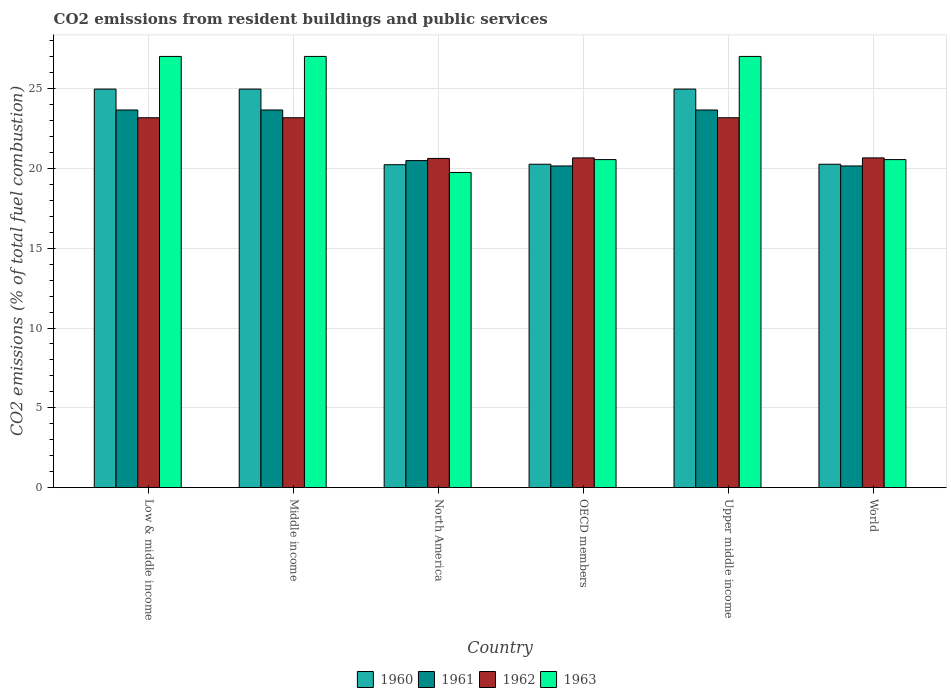How many different coloured bars are there?
Offer a very short reply. 4. How many bars are there on the 5th tick from the left?
Provide a succinct answer. 4. How many bars are there on the 2nd tick from the right?
Offer a very short reply. 4. In how many cases, is the number of bars for a given country not equal to the number of legend labels?
Your answer should be compact. 0. What is the total CO2 emitted in 1961 in World?
Your response must be concise. 20.15. Across all countries, what is the maximum total CO2 emitted in 1962?
Your answer should be compact. 23.17. Across all countries, what is the minimum total CO2 emitted in 1961?
Ensure brevity in your answer.  20.15. In which country was the total CO2 emitted in 1962 minimum?
Provide a succinct answer. North America. What is the total total CO2 emitted in 1962 in the graph?
Keep it short and to the point. 131.46. What is the difference between the total CO2 emitted in 1963 in OECD members and that in Upper middle income?
Provide a succinct answer. -6.46. What is the difference between the total CO2 emitted in 1963 in Upper middle income and the total CO2 emitted in 1962 in Middle income?
Give a very brief answer. 3.84. What is the average total CO2 emitted in 1960 per country?
Keep it short and to the point. 22.61. What is the difference between the total CO2 emitted of/in 1963 and total CO2 emitted of/in 1960 in World?
Offer a very short reply. 0.29. In how many countries, is the total CO2 emitted in 1961 greater than 6?
Provide a succinct answer. 6. What is the ratio of the total CO2 emitted in 1963 in Low & middle income to that in North America?
Make the answer very short. 1.37. Is the total CO2 emitted in 1962 in Low & middle income less than that in North America?
Offer a terse response. No. Is the difference between the total CO2 emitted in 1963 in OECD members and World greater than the difference between the total CO2 emitted in 1960 in OECD members and World?
Make the answer very short. No. What is the difference between the highest and the lowest total CO2 emitted in 1963?
Ensure brevity in your answer.  7.27. In how many countries, is the total CO2 emitted in 1960 greater than the average total CO2 emitted in 1960 taken over all countries?
Give a very brief answer. 3. Is it the case that in every country, the sum of the total CO2 emitted in 1962 and total CO2 emitted in 1961 is greater than the sum of total CO2 emitted in 1960 and total CO2 emitted in 1963?
Offer a very short reply. Yes. How many countries are there in the graph?
Keep it short and to the point. 6. What is the difference between two consecutive major ticks on the Y-axis?
Ensure brevity in your answer.  5. Does the graph contain any zero values?
Give a very brief answer. No. Does the graph contain grids?
Your answer should be very brief. Yes. Where does the legend appear in the graph?
Ensure brevity in your answer.  Bottom center. How many legend labels are there?
Ensure brevity in your answer.  4. How are the legend labels stacked?
Make the answer very short. Horizontal. What is the title of the graph?
Provide a short and direct response. CO2 emissions from resident buildings and public services. Does "1994" appear as one of the legend labels in the graph?
Ensure brevity in your answer.  No. What is the label or title of the Y-axis?
Offer a terse response. CO2 emissions (% of total fuel combustion). What is the CO2 emissions (% of total fuel combustion) of 1960 in Low & middle income?
Keep it short and to the point. 24.97. What is the CO2 emissions (% of total fuel combustion) of 1961 in Low & middle income?
Offer a terse response. 23.66. What is the CO2 emissions (% of total fuel combustion) of 1962 in Low & middle income?
Give a very brief answer. 23.17. What is the CO2 emissions (% of total fuel combustion) in 1963 in Low & middle income?
Provide a succinct answer. 27.01. What is the CO2 emissions (% of total fuel combustion) in 1960 in Middle income?
Offer a terse response. 24.97. What is the CO2 emissions (% of total fuel combustion) of 1961 in Middle income?
Give a very brief answer. 23.66. What is the CO2 emissions (% of total fuel combustion) of 1962 in Middle income?
Give a very brief answer. 23.17. What is the CO2 emissions (% of total fuel combustion) of 1963 in Middle income?
Your answer should be very brief. 27.01. What is the CO2 emissions (% of total fuel combustion) in 1960 in North America?
Keep it short and to the point. 20.23. What is the CO2 emissions (% of total fuel combustion) in 1961 in North America?
Your response must be concise. 20.49. What is the CO2 emissions (% of total fuel combustion) of 1962 in North America?
Your response must be concise. 20.62. What is the CO2 emissions (% of total fuel combustion) of 1963 in North America?
Give a very brief answer. 19.74. What is the CO2 emissions (% of total fuel combustion) in 1960 in OECD members?
Your answer should be very brief. 20.26. What is the CO2 emissions (% of total fuel combustion) of 1961 in OECD members?
Give a very brief answer. 20.15. What is the CO2 emissions (% of total fuel combustion) in 1962 in OECD members?
Provide a short and direct response. 20.66. What is the CO2 emissions (% of total fuel combustion) in 1963 in OECD members?
Provide a short and direct response. 20.55. What is the CO2 emissions (% of total fuel combustion) of 1960 in Upper middle income?
Provide a short and direct response. 24.97. What is the CO2 emissions (% of total fuel combustion) in 1961 in Upper middle income?
Offer a very short reply. 23.66. What is the CO2 emissions (% of total fuel combustion) of 1962 in Upper middle income?
Offer a terse response. 23.17. What is the CO2 emissions (% of total fuel combustion) of 1963 in Upper middle income?
Ensure brevity in your answer.  27.01. What is the CO2 emissions (% of total fuel combustion) of 1960 in World?
Provide a succinct answer. 20.26. What is the CO2 emissions (% of total fuel combustion) in 1961 in World?
Give a very brief answer. 20.15. What is the CO2 emissions (% of total fuel combustion) of 1962 in World?
Make the answer very short. 20.66. What is the CO2 emissions (% of total fuel combustion) in 1963 in World?
Offer a terse response. 20.55. Across all countries, what is the maximum CO2 emissions (% of total fuel combustion) of 1960?
Your response must be concise. 24.97. Across all countries, what is the maximum CO2 emissions (% of total fuel combustion) of 1961?
Offer a very short reply. 23.66. Across all countries, what is the maximum CO2 emissions (% of total fuel combustion) of 1962?
Provide a succinct answer. 23.17. Across all countries, what is the maximum CO2 emissions (% of total fuel combustion) in 1963?
Offer a terse response. 27.01. Across all countries, what is the minimum CO2 emissions (% of total fuel combustion) of 1960?
Your answer should be compact. 20.23. Across all countries, what is the minimum CO2 emissions (% of total fuel combustion) in 1961?
Offer a very short reply. 20.15. Across all countries, what is the minimum CO2 emissions (% of total fuel combustion) in 1962?
Your response must be concise. 20.62. Across all countries, what is the minimum CO2 emissions (% of total fuel combustion) of 1963?
Offer a very short reply. 19.74. What is the total CO2 emissions (% of total fuel combustion) of 1960 in the graph?
Your answer should be very brief. 135.66. What is the total CO2 emissions (% of total fuel combustion) in 1961 in the graph?
Your response must be concise. 131.78. What is the total CO2 emissions (% of total fuel combustion) in 1962 in the graph?
Provide a short and direct response. 131.46. What is the total CO2 emissions (% of total fuel combustion) of 1963 in the graph?
Your response must be concise. 141.89. What is the difference between the CO2 emissions (% of total fuel combustion) in 1963 in Low & middle income and that in Middle income?
Give a very brief answer. 0. What is the difference between the CO2 emissions (% of total fuel combustion) of 1960 in Low & middle income and that in North America?
Your answer should be very brief. 4.74. What is the difference between the CO2 emissions (% of total fuel combustion) of 1961 in Low & middle income and that in North America?
Provide a succinct answer. 3.17. What is the difference between the CO2 emissions (% of total fuel combustion) in 1962 in Low & middle income and that in North America?
Keep it short and to the point. 2.55. What is the difference between the CO2 emissions (% of total fuel combustion) of 1963 in Low & middle income and that in North America?
Offer a terse response. 7.27. What is the difference between the CO2 emissions (% of total fuel combustion) in 1960 in Low & middle income and that in OECD members?
Provide a succinct answer. 4.71. What is the difference between the CO2 emissions (% of total fuel combustion) of 1961 in Low & middle income and that in OECD members?
Provide a short and direct response. 3.51. What is the difference between the CO2 emissions (% of total fuel combustion) of 1962 in Low & middle income and that in OECD members?
Keep it short and to the point. 2.52. What is the difference between the CO2 emissions (% of total fuel combustion) of 1963 in Low & middle income and that in OECD members?
Ensure brevity in your answer.  6.46. What is the difference between the CO2 emissions (% of total fuel combustion) in 1960 in Low & middle income and that in Upper middle income?
Provide a succinct answer. 0. What is the difference between the CO2 emissions (% of total fuel combustion) of 1962 in Low & middle income and that in Upper middle income?
Offer a very short reply. 0. What is the difference between the CO2 emissions (% of total fuel combustion) in 1963 in Low & middle income and that in Upper middle income?
Give a very brief answer. 0. What is the difference between the CO2 emissions (% of total fuel combustion) in 1960 in Low & middle income and that in World?
Offer a very short reply. 4.71. What is the difference between the CO2 emissions (% of total fuel combustion) of 1961 in Low & middle income and that in World?
Your answer should be very brief. 3.51. What is the difference between the CO2 emissions (% of total fuel combustion) in 1962 in Low & middle income and that in World?
Make the answer very short. 2.52. What is the difference between the CO2 emissions (% of total fuel combustion) of 1963 in Low & middle income and that in World?
Your answer should be compact. 6.46. What is the difference between the CO2 emissions (% of total fuel combustion) in 1960 in Middle income and that in North America?
Ensure brevity in your answer.  4.74. What is the difference between the CO2 emissions (% of total fuel combustion) in 1961 in Middle income and that in North America?
Your answer should be very brief. 3.17. What is the difference between the CO2 emissions (% of total fuel combustion) in 1962 in Middle income and that in North America?
Provide a short and direct response. 2.55. What is the difference between the CO2 emissions (% of total fuel combustion) of 1963 in Middle income and that in North America?
Make the answer very short. 7.27. What is the difference between the CO2 emissions (% of total fuel combustion) of 1960 in Middle income and that in OECD members?
Your answer should be very brief. 4.71. What is the difference between the CO2 emissions (% of total fuel combustion) in 1961 in Middle income and that in OECD members?
Offer a very short reply. 3.51. What is the difference between the CO2 emissions (% of total fuel combustion) of 1962 in Middle income and that in OECD members?
Keep it short and to the point. 2.52. What is the difference between the CO2 emissions (% of total fuel combustion) in 1963 in Middle income and that in OECD members?
Keep it short and to the point. 6.46. What is the difference between the CO2 emissions (% of total fuel combustion) in 1962 in Middle income and that in Upper middle income?
Provide a short and direct response. 0. What is the difference between the CO2 emissions (% of total fuel combustion) of 1960 in Middle income and that in World?
Your answer should be very brief. 4.71. What is the difference between the CO2 emissions (% of total fuel combustion) of 1961 in Middle income and that in World?
Make the answer very short. 3.51. What is the difference between the CO2 emissions (% of total fuel combustion) of 1962 in Middle income and that in World?
Your answer should be very brief. 2.52. What is the difference between the CO2 emissions (% of total fuel combustion) in 1963 in Middle income and that in World?
Ensure brevity in your answer.  6.46. What is the difference between the CO2 emissions (% of total fuel combustion) in 1960 in North America and that in OECD members?
Your response must be concise. -0.03. What is the difference between the CO2 emissions (% of total fuel combustion) of 1961 in North America and that in OECD members?
Offer a terse response. 0.34. What is the difference between the CO2 emissions (% of total fuel combustion) in 1962 in North America and that in OECD members?
Ensure brevity in your answer.  -0.03. What is the difference between the CO2 emissions (% of total fuel combustion) of 1963 in North America and that in OECD members?
Offer a very short reply. -0.81. What is the difference between the CO2 emissions (% of total fuel combustion) of 1960 in North America and that in Upper middle income?
Provide a short and direct response. -4.74. What is the difference between the CO2 emissions (% of total fuel combustion) of 1961 in North America and that in Upper middle income?
Give a very brief answer. -3.17. What is the difference between the CO2 emissions (% of total fuel combustion) in 1962 in North America and that in Upper middle income?
Make the answer very short. -2.55. What is the difference between the CO2 emissions (% of total fuel combustion) of 1963 in North America and that in Upper middle income?
Provide a short and direct response. -7.27. What is the difference between the CO2 emissions (% of total fuel combustion) in 1960 in North America and that in World?
Provide a short and direct response. -0.03. What is the difference between the CO2 emissions (% of total fuel combustion) of 1961 in North America and that in World?
Ensure brevity in your answer.  0.34. What is the difference between the CO2 emissions (% of total fuel combustion) in 1962 in North America and that in World?
Your answer should be compact. -0.03. What is the difference between the CO2 emissions (% of total fuel combustion) in 1963 in North America and that in World?
Keep it short and to the point. -0.81. What is the difference between the CO2 emissions (% of total fuel combustion) in 1960 in OECD members and that in Upper middle income?
Keep it short and to the point. -4.71. What is the difference between the CO2 emissions (% of total fuel combustion) in 1961 in OECD members and that in Upper middle income?
Provide a succinct answer. -3.51. What is the difference between the CO2 emissions (% of total fuel combustion) in 1962 in OECD members and that in Upper middle income?
Offer a very short reply. -2.52. What is the difference between the CO2 emissions (% of total fuel combustion) in 1963 in OECD members and that in Upper middle income?
Offer a terse response. -6.46. What is the difference between the CO2 emissions (% of total fuel combustion) of 1960 in OECD members and that in World?
Keep it short and to the point. 0. What is the difference between the CO2 emissions (% of total fuel combustion) of 1961 in OECD members and that in World?
Provide a short and direct response. 0. What is the difference between the CO2 emissions (% of total fuel combustion) in 1962 in OECD members and that in World?
Provide a short and direct response. 0. What is the difference between the CO2 emissions (% of total fuel combustion) of 1960 in Upper middle income and that in World?
Give a very brief answer. 4.71. What is the difference between the CO2 emissions (% of total fuel combustion) of 1961 in Upper middle income and that in World?
Your answer should be very brief. 3.51. What is the difference between the CO2 emissions (% of total fuel combustion) of 1962 in Upper middle income and that in World?
Provide a succinct answer. 2.52. What is the difference between the CO2 emissions (% of total fuel combustion) in 1963 in Upper middle income and that in World?
Provide a short and direct response. 6.46. What is the difference between the CO2 emissions (% of total fuel combustion) in 1960 in Low & middle income and the CO2 emissions (% of total fuel combustion) in 1961 in Middle income?
Keep it short and to the point. 1.31. What is the difference between the CO2 emissions (% of total fuel combustion) of 1960 in Low & middle income and the CO2 emissions (% of total fuel combustion) of 1962 in Middle income?
Ensure brevity in your answer.  1.8. What is the difference between the CO2 emissions (% of total fuel combustion) of 1960 in Low & middle income and the CO2 emissions (% of total fuel combustion) of 1963 in Middle income?
Ensure brevity in your answer.  -2.05. What is the difference between the CO2 emissions (% of total fuel combustion) in 1961 in Low & middle income and the CO2 emissions (% of total fuel combustion) in 1962 in Middle income?
Offer a terse response. 0.49. What is the difference between the CO2 emissions (% of total fuel combustion) in 1961 in Low & middle income and the CO2 emissions (% of total fuel combustion) in 1963 in Middle income?
Offer a very short reply. -3.35. What is the difference between the CO2 emissions (% of total fuel combustion) in 1962 in Low & middle income and the CO2 emissions (% of total fuel combustion) in 1963 in Middle income?
Offer a very short reply. -3.84. What is the difference between the CO2 emissions (% of total fuel combustion) of 1960 in Low & middle income and the CO2 emissions (% of total fuel combustion) of 1961 in North America?
Your answer should be very brief. 4.48. What is the difference between the CO2 emissions (% of total fuel combustion) of 1960 in Low & middle income and the CO2 emissions (% of total fuel combustion) of 1962 in North America?
Keep it short and to the point. 4.35. What is the difference between the CO2 emissions (% of total fuel combustion) of 1960 in Low & middle income and the CO2 emissions (% of total fuel combustion) of 1963 in North America?
Offer a very short reply. 5.22. What is the difference between the CO2 emissions (% of total fuel combustion) in 1961 in Low & middle income and the CO2 emissions (% of total fuel combustion) in 1962 in North America?
Provide a short and direct response. 3.04. What is the difference between the CO2 emissions (% of total fuel combustion) in 1961 in Low & middle income and the CO2 emissions (% of total fuel combustion) in 1963 in North America?
Ensure brevity in your answer.  3.92. What is the difference between the CO2 emissions (% of total fuel combustion) of 1962 in Low & middle income and the CO2 emissions (% of total fuel combustion) of 1963 in North America?
Offer a very short reply. 3.43. What is the difference between the CO2 emissions (% of total fuel combustion) in 1960 in Low & middle income and the CO2 emissions (% of total fuel combustion) in 1961 in OECD members?
Keep it short and to the point. 4.82. What is the difference between the CO2 emissions (% of total fuel combustion) in 1960 in Low & middle income and the CO2 emissions (% of total fuel combustion) in 1962 in OECD members?
Ensure brevity in your answer.  4.31. What is the difference between the CO2 emissions (% of total fuel combustion) in 1960 in Low & middle income and the CO2 emissions (% of total fuel combustion) in 1963 in OECD members?
Provide a short and direct response. 4.42. What is the difference between the CO2 emissions (% of total fuel combustion) of 1961 in Low & middle income and the CO2 emissions (% of total fuel combustion) of 1962 in OECD members?
Make the answer very short. 3. What is the difference between the CO2 emissions (% of total fuel combustion) in 1961 in Low & middle income and the CO2 emissions (% of total fuel combustion) in 1963 in OECD members?
Keep it short and to the point. 3.11. What is the difference between the CO2 emissions (% of total fuel combustion) in 1962 in Low & middle income and the CO2 emissions (% of total fuel combustion) in 1963 in OECD members?
Offer a very short reply. 2.62. What is the difference between the CO2 emissions (% of total fuel combustion) of 1960 in Low & middle income and the CO2 emissions (% of total fuel combustion) of 1961 in Upper middle income?
Provide a succinct answer. 1.31. What is the difference between the CO2 emissions (% of total fuel combustion) in 1960 in Low & middle income and the CO2 emissions (% of total fuel combustion) in 1962 in Upper middle income?
Provide a succinct answer. 1.8. What is the difference between the CO2 emissions (% of total fuel combustion) in 1960 in Low & middle income and the CO2 emissions (% of total fuel combustion) in 1963 in Upper middle income?
Offer a very short reply. -2.05. What is the difference between the CO2 emissions (% of total fuel combustion) in 1961 in Low & middle income and the CO2 emissions (% of total fuel combustion) in 1962 in Upper middle income?
Make the answer very short. 0.49. What is the difference between the CO2 emissions (% of total fuel combustion) in 1961 in Low & middle income and the CO2 emissions (% of total fuel combustion) in 1963 in Upper middle income?
Your answer should be very brief. -3.35. What is the difference between the CO2 emissions (% of total fuel combustion) in 1962 in Low & middle income and the CO2 emissions (% of total fuel combustion) in 1963 in Upper middle income?
Offer a terse response. -3.84. What is the difference between the CO2 emissions (% of total fuel combustion) in 1960 in Low & middle income and the CO2 emissions (% of total fuel combustion) in 1961 in World?
Your response must be concise. 4.82. What is the difference between the CO2 emissions (% of total fuel combustion) in 1960 in Low & middle income and the CO2 emissions (% of total fuel combustion) in 1962 in World?
Provide a succinct answer. 4.31. What is the difference between the CO2 emissions (% of total fuel combustion) in 1960 in Low & middle income and the CO2 emissions (% of total fuel combustion) in 1963 in World?
Your response must be concise. 4.42. What is the difference between the CO2 emissions (% of total fuel combustion) in 1961 in Low & middle income and the CO2 emissions (% of total fuel combustion) in 1962 in World?
Your response must be concise. 3. What is the difference between the CO2 emissions (% of total fuel combustion) of 1961 in Low & middle income and the CO2 emissions (% of total fuel combustion) of 1963 in World?
Provide a short and direct response. 3.11. What is the difference between the CO2 emissions (% of total fuel combustion) of 1962 in Low & middle income and the CO2 emissions (% of total fuel combustion) of 1963 in World?
Provide a succinct answer. 2.62. What is the difference between the CO2 emissions (% of total fuel combustion) in 1960 in Middle income and the CO2 emissions (% of total fuel combustion) in 1961 in North America?
Your answer should be very brief. 4.48. What is the difference between the CO2 emissions (% of total fuel combustion) of 1960 in Middle income and the CO2 emissions (% of total fuel combustion) of 1962 in North America?
Ensure brevity in your answer.  4.35. What is the difference between the CO2 emissions (% of total fuel combustion) of 1960 in Middle income and the CO2 emissions (% of total fuel combustion) of 1963 in North America?
Offer a terse response. 5.22. What is the difference between the CO2 emissions (% of total fuel combustion) of 1961 in Middle income and the CO2 emissions (% of total fuel combustion) of 1962 in North America?
Your answer should be compact. 3.04. What is the difference between the CO2 emissions (% of total fuel combustion) of 1961 in Middle income and the CO2 emissions (% of total fuel combustion) of 1963 in North America?
Provide a succinct answer. 3.92. What is the difference between the CO2 emissions (% of total fuel combustion) in 1962 in Middle income and the CO2 emissions (% of total fuel combustion) in 1963 in North America?
Make the answer very short. 3.43. What is the difference between the CO2 emissions (% of total fuel combustion) in 1960 in Middle income and the CO2 emissions (% of total fuel combustion) in 1961 in OECD members?
Your answer should be compact. 4.82. What is the difference between the CO2 emissions (% of total fuel combustion) of 1960 in Middle income and the CO2 emissions (% of total fuel combustion) of 1962 in OECD members?
Provide a succinct answer. 4.31. What is the difference between the CO2 emissions (% of total fuel combustion) in 1960 in Middle income and the CO2 emissions (% of total fuel combustion) in 1963 in OECD members?
Your answer should be very brief. 4.42. What is the difference between the CO2 emissions (% of total fuel combustion) in 1961 in Middle income and the CO2 emissions (% of total fuel combustion) in 1962 in OECD members?
Keep it short and to the point. 3. What is the difference between the CO2 emissions (% of total fuel combustion) of 1961 in Middle income and the CO2 emissions (% of total fuel combustion) of 1963 in OECD members?
Provide a succinct answer. 3.11. What is the difference between the CO2 emissions (% of total fuel combustion) in 1962 in Middle income and the CO2 emissions (% of total fuel combustion) in 1963 in OECD members?
Provide a short and direct response. 2.62. What is the difference between the CO2 emissions (% of total fuel combustion) of 1960 in Middle income and the CO2 emissions (% of total fuel combustion) of 1961 in Upper middle income?
Your answer should be very brief. 1.31. What is the difference between the CO2 emissions (% of total fuel combustion) in 1960 in Middle income and the CO2 emissions (% of total fuel combustion) in 1962 in Upper middle income?
Give a very brief answer. 1.8. What is the difference between the CO2 emissions (% of total fuel combustion) in 1960 in Middle income and the CO2 emissions (% of total fuel combustion) in 1963 in Upper middle income?
Provide a succinct answer. -2.05. What is the difference between the CO2 emissions (% of total fuel combustion) in 1961 in Middle income and the CO2 emissions (% of total fuel combustion) in 1962 in Upper middle income?
Offer a very short reply. 0.49. What is the difference between the CO2 emissions (% of total fuel combustion) of 1961 in Middle income and the CO2 emissions (% of total fuel combustion) of 1963 in Upper middle income?
Your response must be concise. -3.35. What is the difference between the CO2 emissions (% of total fuel combustion) in 1962 in Middle income and the CO2 emissions (% of total fuel combustion) in 1963 in Upper middle income?
Provide a short and direct response. -3.84. What is the difference between the CO2 emissions (% of total fuel combustion) in 1960 in Middle income and the CO2 emissions (% of total fuel combustion) in 1961 in World?
Make the answer very short. 4.82. What is the difference between the CO2 emissions (% of total fuel combustion) of 1960 in Middle income and the CO2 emissions (% of total fuel combustion) of 1962 in World?
Make the answer very short. 4.31. What is the difference between the CO2 emissions (% of total fuel combustion) of 1960 in Middle income and the CO2 emissions (% of total fuel combustion) of 1963 in World?
Make the answer very short. 4.42. What is the difference between the CO2 emissions (% of total fuel combustion) in 1961 in Middle income and the CO2 emissions (% of total fuel combustion) in 1962 in World?
Offer a terse response. 3. What is the difference between the CO2 emissions (% of total fuel combustion) in 1961 in Middle income and the CO2 emissions (% of total fuel combustion) in 1963 in World?
Offer a very short reply. 3.11. What is the difference between the CO2 emissions (% of total fuel combustion) in 1962 in Middle income and the CO2 emissions (% of total fuel combustion) in 1963 in World?
Your answer should be very brief. 2.62. What is the difference between the CO2 emissions (% of total fuel combustion) in 1960 in North America and the CO2 emissions (% of total fuel combustion) in 1961 in OECD members?
Give a very brief answer. 0.08. What is the difference between the CO2 emissions (% of total fuel combustion) in 1960 in North America and the CO2 emissions (% of total fuel combustion) in 1962 in OECD members?
Give a very brief answer. -0.43. What is the difference between the CO2 emissions (% of total fuel combustion) of 1960 in North America and the CO2 emissions (% of total fuel combustion) of 1963 in OECD members?
Offer a very short reply. -0.32. What is the difference between the CO2 emissions (% of total fuel combustion) of 1961 in North America and the CO2 emissions (% of total fuel combustion) of 1962 in OECD members?
Offer a terse response. -0.17. What is the difference between the CO2 emissions (% of total fuel combustion) in 1961 in North America and the CO2 emissions (% of total fuel combustion) in 1963 in OECD members?
Give a very brief answer. -0.06. What is the difference between the CO2 emissions (% of total fuel combustion) in 1962 in North America and the CO2 emissions (% of total fuel combustion) in 1963 in OECD members?
Offer a very short reply. 0.07. What is the difference between the CO2 emissions (% of total fuel combustion) of 1960 in North America and the CO2 emissions (% of total fuel combustion) of 1961 in Upper middle income?
Give a very brief answer. -3.43. What is the difference between the CO2 emissions (% of total fuel combustion) in 1960 in North America and the CO2 emissions (% of total fuel combustion) in 1962 in Upper middle income?
Ensure brevity in your answer.  -2.94. What is the difference between the CO2 emissions (% of total fuel combustion) in 1960 in North America and the CO2 emissions (% of total fuel combustion) in 1963 in Upper middle income?
Offer a terse response. -6.78. What is the difference between the CO2 emissions (% of total fuel combustion) of 1961 in North America and the CO2 emissions (% of total fuel combustion) of 1962 in Upper middle income?
Your answer should be very brief. -2.68. What is the difference between the CO2 emissions (% of total fuel combustion) in 1961 in North America and the CO2 emissions (% of total fuel combustion) in 1963 in Upper middle income?
Keep it short and to the point. -6.53. What is the difference between the CO2 emissions (% of total fuel combustion) of 1962 in North America and the CO2 emissions (% of total fuel combustion) of 1963 in Upper middle income?
Your answer should be very brief. -6.39. What is the difference between the CO2 emissions (% of total fuel combustion) of 1960 in North America and the CO2 emissions (% of total fuel combustion) of 1961 in World?
Offer a terse response. 0.08. What is the difference between the CO2 emissions (% of total fuel combustion) in 1960 in North America and the CO2 emissions (% of total fuel combustion) in 1962 in World?
Your answer should be very brief. -0.43. What is the difference between the CO2 emissions (% of total fuel combustion) of 1960 in North America and the CO2 emissions (% of total fuel combustion) of 1963 in World?
Offer a very short reply. -0.32. What is the difference between the CO2 emissions (% of total fuel combustion) of 1961 in North America and the CO2 emissions (% of total fuel combustion) of 1962 in World?
Offer a very short reply. -0.17. What is the difference between the CO2 emissions (% of total fuel combustion) of 1961 in North America and the CO2 emissions (% of total fuel combustion) of 1963 in World?
Your response must be concise. -0.06. What is the difference between the CO2 emissions (% of total fuel combustion) of 1962 in North America and the CO2 emissions (% of total fuel combustion) of 1963 in World?
Make the answer very short. 0.07. What is the difference between the CO2 emissions (% of total fuel combustion) of 1960 in OECD members and the CO2 emissions (% of total fuel combustion) of 1961 in Upper middle income?
Your answer should be compact. -3.4. What is the difference between the CO2 emissions (% of total fuel combustion) in 1960 in OECD members and the CO2 emissions (% of total fuel combustion) in 1962 in Upper middle income?
Keep it short and to the point. -2.91. What is the difference between the CO2 emissions (% of total fuel combustion) of 1960 in OECD members and the CO2 emissions (% of total fuel combustion) of 1963 in Upper middle income?
Ensure brevity in your answer.  -6.75. What is the difference between the CO2 emissions (% of total fuel combustion) of 1961 in OECD members and the CO2 emissions (% of total fuel combustion) of 1962 in Upper middle income?
Make the answer very short. -3.02. What is the difference between the CO2 emissions (% of total fuel combustion) of 1961 in OECD members and the CO2 emissions (% of total fuel combustion) of 1963 in Upper middle income?
Your answer should be compact. -6.86. What is the difference between the CO2 emissions (% of total fuel combustion) in 1962 in OECD members and the CO2 emissions (% of total fuel combustion) in 1963 in Upper middle income?
Make the answer very short. -6.36. What is the difference between the CO2 emissions (% of total fuel combustion) of 1960 in OECD members and the CO2 emissions (% of total fuel combustion) of 1961 in World?
Offer a terse response. 0.11. What is the difference between the CO2 emissions (% of total fuel combustion) in 1960 in OECD members and the CO2 emissions (% of total fuel combustion) in 1962 in World?
Give a very brief answer. -0.4. What is the difference between the CO2 emissions (% of total fuel combustion) of 1960 in OECD members and the CO2 emissions (% of total fuel combustion) of 1963 in World?
Your answer should be compact. -0.29. What is the difference between the CO2 emissions (% of total fuel combustion) in 1961 in OECD members and the CO2 emissions (% of total fuel combustion) in 1962 in World?
Provide a succinct answer. -0.5. What is the difference between the CO2 emissions (% of total fuel combustion) in 1961 in OECD members and the CO2 emissions (% of total fuel combustion) in 1963 in World?
Your answer should be very brief. -0.4. What is the difference between the CO2 emissions (% of total fuel combustion) in 1962 in OECD members and the CO2 emissions (% of total fuel combustion) in 1963 in World?
Your answer should be compact. 0.11. What is the difference between the CO2 emissions (% of total fuel combustion) of 1960 in Upper middle income and the CO2 emissions (% of total fuel combustion) of 1961 in World?
Your answer should be compact. 4.82. What is the difference between the CO2 emissions (% of total fuel combustion) in 1960 in Upper middle income and the CO2 emissions (% of total fuel combustion) in 1962 in World?
Offer a very short reply. 4.31. What is the difference between the CO2 emissions (% of total fuel combustion) of 1960 in Upper middle income and the CO2 emissions (% of total fuel combustion) of 1963 in World?
Keep it short and to the point. 4.42. What is the difference between the CO2 emissions (% of total fuel combustion) of 1961 in Upper middle income and the CO2 emissions (% of total fuel combustion) of 1962 in World?
Ensure brevity in your answer.  3. What is the difference between the CO2 emissions (% of total fuel combustion) of 1961 in Upper middle income and the CO2 emissions (% of total fuel combustion) of 1963 in World?
Ensure brevity in your answer.  3.11. What is the difference between the CO2 emissions (% of total fuel combustion) in 1962 in Upper middle income and the CO2 emissions (% of total fuel combustion) in 1963 in World?
Give a very brief answer. 2.62. What is the average CO2 emissions (% of total fuel combustion) in 1960 per country?
Ensure brevity in your answer.  22.61. What is the average CO2 emissions (% of total fuel combustion) of 1961 per country?
Your answer should be very brief. 21.96. What is the average CO2 emissions (% of total fuel combustion) in 1962 per country?
Give a very brief answer. 21.91. What is the average CO2 emissions (% of total fuel combustion) in 1963 per country?
Your response must be concise. 23.65. What is the difference between the CO2 emissions (% of total fuel combustion) of 1960 and CO2 emissions (% of total fuel combustion) of 1961 in Low & middle income?
Make the answer very short. 1.31. What is the difference between the CO2 emissions (% of total fuel combustion) of 1960 and CO2 emissions (% of total fuel combustion) of 1962 in Low & middle income?
Provide a short and direct response. 1.8. What is the difference between the CO2 emissions (% of total fuel combustion) in 1960 and CO2 emissions (% of total fuel combustion) in 1963 in Low & middle income?
Your answer should be compact. -2.05. What is the difference between the CO2 emissions (% of total fuel combustion) of 1961 and CO2 emissions (% of total fuel combustion) of 1962 in Low & middle income?
Provide a short and direct response. 0.49. What is the difference between the CO2 emissions (% of total fuel combustion) in 1961 and CO2 emissions (% of total fuel combustion) in 1963 in Low & middle income?
Your response must be concise. -3.35. What is the difference between the CO2 emissions (% of total fuel combustion) of 1962 and CO2 emissions (% of total fuel combustion) of 1963 in Low & middle income?
Offer a very short reply. -3.84. What is the difference between the CO2 emissions (% of total fuel combustion) in 1960 and CO2 emissions (% of total fuel combustion) in 1961 in Middle income?
Your response must be concise. 1.31. What is the difference between the CO2 emissions (% of total fuel combustion) in 1960 and CO2 emissions (% of total fuel combustion) in 1962 in Middle income?
Your answer should be very brief. 1.8. What is the difference between the CO2 emissions (% of total fuel combustion) in 1960 and CO2 emissions (% of total fuel combustion) in 1963 in Middle income?
Your response must be concise. -2.05. What is the difference between the CO2 emissions (% of total fuel combustion) of 1961 and CO2 emissions (% of total fuel combustion) of 1962 in Middle income?
Offer a very short reply. 0.49. What is the difference between the CO2 emissions (% of total fuel combustion) in 1961 and CO2 emissions (% of total fuel combustion) in 1963 in Middle income?
Your answer should be very brief. -3.35. What is the difference between the CO2 emissions (% of total fuel combustion) of 1962 and CO2 emissions (% of total fuel combustion) of 1963 in Middle income?
Your answer should be very brief. -3.84. What is the difference between the CO2 emissions (% of total fuel combustion) in 1960 and CO2 emissions (% of total fuel combustion) in 1961 in North America?
Your response must be concise. -0.26. What is the difference between the CO2 emissions (% of total fuel combustion) of 1960 and CO2 emissions (% of total fuel combustion) of 1962 in North America?
Provide a short and direct response. -0.39. What is the difference between the CO2 emissions (% of total fuel combustion) in 1960 and CO2 emissions (% of total fuel combustion) in 1963 in North America?
Keep it short and to the point. 0.49. What is the difference between the CO2 emissions (% of total fuel combustion) in 1961 and CO2 emissions (% of total fuel combustion) in 1962 in North America?
Your response must be concise. -0.14. What is the difference between the CO2 emissions (% of total fuel combustion) of 1961 and CO2 emissions (% of total fuel combustion) of 1963 in North America?
Ensure brevity in your answer.  0.74. What is the difference between the CO2 emissions (% of total fuel combustion) in 1962 and CO2 emissions (% of total fuel combustion) in 1963 in North America?
Keep it short and to the point. 0.88. What is the difference between the CO2 emissions (% of total fuel combustion) in 1960 and CO2 emissions (% of total fuel combustion) in 1961 in OECD members?
Make the answer very short. 0.11. What is the difference between the CO2 emissions (% of total fuel combustion) of 1960 and CO2 emissions (% of total fuel combustion) of 1962 in OECD members?
Offer a very short reply. -0.4. What is the difference between the CO2 emissions (% of total fuel combustion) of 1960 and CO2 emissions (% of total fuel combustion) of 1963 in OECD members?
Provide a short and direct response. -0.29. What is the difference between the CO2 emissions (% of total fuel combustion) of 1961 and CO2 emissions (% of total fuel combustion) of 1962 in OECD members?
Offer a terse response. -0.5. What is the difference between the CO2 emissions (% of total fuel combustion) of 1961 and CO2 emissions (% of total fuel combustion) of 1963 in OECD members?
Your answer should be compact. -0.4. What is the difference between the CO2 emissions (% of total fuel combustion) of 1962 and CO2 emissions (% of total fuel combustion) of 1963 in OECD members?
Provide a short and direct response. 0.11. What is the difference between the CO2 emissions (% of total fuel combustion) in 1960 and CO2 emissions (% of total fuel combustion) in 1961 in Upper middle income?
Offer a terse response. 1.31. What is the difference between the CO2 emissions (% of total fuel combustion) of 1960 and CO2 emissions (% of total fuel combustion) of 1962 in Upper middle income?
Your answer should be compact. 1.8. What is the difference between the CO2 emissions (% of total fuel combustion) in 1960 and CO2 emissions (% of total fuel combustion) in 1963 in Upper middle income?
Give a very brief answer. -2.05. What is the difference between the CO2 emissions (% of total fuel combustion) in 1961 and CO2 emissions (% of total fuel combustion) in 1962 in Upper middle income?
Provide a succinct answer. 0.49. What is the difference between the CO2 emissions (% of total fuel combustion) of 1961 and CO2 emissions (% of total fuel combustion) of 1963 in Upper middle income?
Offer a very short reply. -3.35. What is the difference between the CO2 emissions (% of total fuel combustion) in 1962 and CO2 emissions (% of total fuel combustion) in 1963 in Upper middle income?
Offer a very short reply. -3.84. What is the difference between the CO2 emissions (% of total fuel combustion) in 1960 and CO2 emissions (% of total fuel combustion) in 1961 in World?
Give a very brief answer. 0.11. What is the difference between the CO2 emissions (% of total fuel combustion) in 1960 and CO2 emissions (% of total fuel combustion) in 1962 in World?
Offer a terse response. -0.4. What is the difference between the CO2 emissions (% of total fuel combustion) in 1960 and CO2 emissions (% of total fuel combustion) in 1963 in World?
Your response must be concise. -0.29. What is the difference between the CO2 emissions (% of total fuel combustion) of 1961 and CO2 emissions (% of total fuel combustion) of 1962 in World?
Offer a terse response. -0.5. What is the difference between the CO2 emissions (% of total fuel combustion) in 1961 and CO2 emissions (% of total fuel combustion) in 1963 in World?
Offer a very short reply. -0.4. What is the difference between the CO2 emissions (% of total fuel combustion) in 1962 and CO2 emissions (% of total fuel combustion) in 1963 in World?
Keep it short and to the point. 0.11. What is the ratio of the CO2 emissions (% of total fuel combustion) of 1962 in Low & middle income to that in Middle income?
Provide a short and direct response. 1. What is the ratio of the CO2 emissions (% of total fuel combustion) in 1963 in Low & middle income to that in Middle income?
Provide a short and direct response. 1. What is the ratio of the CO2 emissions (% of total fuel combustion) of 1960 in Low & middle income to that in North America?
Keep it short and to the point. 1.23. What is the ratio of the CO2 emissions (% of total fuel combustion) in 1961 in Low & middle income to that in North America?
Provide a succinct answer. 1.15. What is the ratio of the CO2 emissions (% of total fuel combustion) of 1962 in Low & middle income to that in North America?
Provide a succinct answer. 1.12. What is the ratio of the CO2 emissions (% of total fuel combustion) in 1963 in Low & middle income to that in North America?
Provide a short and direct response. 1.37. What is the ratio of the CO2 emissions (% of total fuel combustion) in 1960 in Low & middle income to that in OECD members?
Offer a very short reply. 1.23. What is the ratio of the CO2 emissions (% of total fuel combustion) in 1961 in Low & middle income to that in OECD members?
Offer a terse response. 1.17. What is the ratio of the CO2 emissions (% of total fuel combustion) of 1962 in Low & middle income to that in OECD members?
Your answer should be very brief. 1.12. What is the ratio of the CO2 emissions (% of total fuel combustion) of 1963 in Low & middle income to that in OECD members?
Offer a terse response. 1.31. What is the ratio of the CO2 emissions (% of total fuel combustion) in 1960 in Low & middle income to that in World?
Keep it short and to the point. 1.23. What is the ratio of the CO2 emissions (% of total fuel combustion) of 1961 in Low & middle income to that in World?
Your answer should be compact. 1.17. What is the ratio of the CO2 emissions (% of total fuel combustion) of 1962 in Low & middle income to that in World?
Your answer should be compact. 1.12. What is the ratio of the CO2 emissions (% of total fuel combustion) of 1963 in Low & middle income to that in World?
Your answer should be very brief. 1.31. What is the ratio of the CO2 emissions (% of total fuel combustion) of 1960 in Middle income to that in North America?
Make the answer very short. 1.23. What is the ratio of the CO2 emissions (% of total fuel combustion) of 1961 in Middle income to that in North America?
Give a very brief answer. 1.15. What is the ratio of the CO2 emissions (% of total fuel combustion) in 1962 in Middle income to that in North America?
Your answer should be very brief. 1.12. What is the ratio of the CO2 emissions (% of total fuel combustion) in 1963 in Middle income to that in North America?
Your answer should be very brief. 1.37. What is the ratio of the CO2 emissions (% of total fuel combustion) of 1960 in Middle income to that in OECD members?
Make the answer very short. 1.23. What is the ratio of the CO2 emissions (% of total fuel combustion) in 1961 in Middle income to that in OECD members?
Make the answer very short. 1.17. What is the ratio of the CO2 emissions (% of total fuel combustion) of 1962 in Middle income to that in OECD members?
Give a very brief answer. 1.12. What is the ratio of the CO2 emissions (% of total fuel combustion) in 1963 in Middle income to that in OECD members?
Ensure brevity in your answer.  1.31. What is the ratio of the CO2 emissions (% of total fuel combustion) of 1960 in Middle income to that in Upper middle income?
Give a very brief answer. 1. What is the ratio of the CO2 emissions (% of total fuel combustion) of 1961 in Middle income to that in Upper middle income?
Ensure brevity in your answer.  1. What is the ratio of the CO2 emissions (% of total fuel combustion) of 1963 in Middle income to that in Upper middle income?
Make the answer very short. 1. What is the ratio of the CO2 emissions (% of total fuel combustion) of 1960 in Middle income to that in World?
Offer a terse response. 1.23. What is the ratio of the CO2 emissions (% of total fuel combustion) of 1961 in Middle income to that in World?
Give a very brief answer. 1.17. What is the ratio of the CO2 emissions (% of total fuel combustion) of 1962 in Middle income to that in World?
Provide a succinct answer. 1.12. What is the ratio of the CO2 emissions (% of total fuel combustion) of 1963 in Middle income to that in World?
Your response must be concise. 1.31. What is the ratio of the CO2 emissions (% of total fuel combustion) in 1961 in North America to that in OECD members?
Offer a terse response. 1.02. What is the ratio of the CO2 emissions (% of total fuel combustion) of 1963 in North America to that in OECD members?
Offer a terse response. 0.96. What is the ratio of the CO2 emissions (% of total fuel combustion) of 1960 in North America to that in Upper middle income?
Offer a terse response. 0.81. What is the ratio of the CO2 emissions (% of total fuel combustion) of 1961 in North America to that in Upper middle income?
Provide a succinct answer. 0.87. What is the ratio of the CO2 emissions (% of total fuel combustion) of 1962 in North America to that in Upper middle income?
Provide a short and direct response. 0.89. What is the ratio of the CO2 emissions (% of total fuel combustion) of 1963 in North America to that in Upper middle income?
Your response must be concise. 0.73. What is the ratio of the CO2 emissions (% of total fuel combustion) in 1960 in North America to that in World?
Offer a very short reply. 1. What is the ratio of the CO2 emissions (% of total fuel combustion) of 1961 in North America to that in World?
Keep it short and to the point. 1.02. What is the ratio of the CO2 emissions (% of total fuel combustion) in 1962 in North America to that in World?
Your answer should be very brief. 1. What is the ratio of the CO2 emissions (% of total fuel combustion) in 1963 in North America to that in World?
Your answer should be very brief. 0.96. What is the ratio of the CO2 emissions (% of total fuel combustion) of 1960 in OECD members to that in Upper middle income?
Provide a succinct answer. 0.81. What is the ratio of the CO2 emissions (% of total fuel combustion) of 1961 in OECD members to that in Upper middle income?
Your response must be concise. 0.85. What is the ratio of the CO2 emissions (% of total fuel combustion) of 1962 in OECD members to that in Upper middle income?
Offer a very short reply. 0.89. What is the ratio of the CO2 emissions (% of total fuel combustion) in 1963 in OECD members to that in Upper middle income?
Offer a very short reply. 0.76. What is the ratio of the CO2 emissions (% of total fuel combustion) of 1960 in OECD members to that in World?
Provide a succinct answer. 1. What is the ratio of the CO2 emissions (% of total fuel combustion) of 1961 in OECD members to that in World?
Give a very brief answer. 1. What is the ratio of the CO2 emissions (% of total fuel combustion) in 1962 in OECD members to that in World?
Keep it short and to the point. 1. What is the ratio of the CO2 emissions (% of total fuel combustion) of 1963 in OECD members to that in World?
Ensure brevity in your answer.  1. What is the ratio of the CO2 emissions (% of total fuel combustion) of 1960 in Upper middle income to that in World?
Your answer should be very brief. 1.23. What is the ratio of the CO2 emissions (% of total fuel combustion) in 1961 in Upper middle income to that in World?
Offer a very short reply. 1.17. What is the ratio of the CO2 emissions (% of total fuel combustion) of 1962 in Upper middle income to that in World?
Ensure brevity in your answer.  1.12. What is the ratio of the CO2 emissions (% of total fuel combustion) in 1963 in Upper middle income to that in World?
Make the answer very short. 1.31. What is the difference between the highest and the second highest CO2 emissions (% of total fuel combustion) of 1961?
Offer a very short reply. 0. What is the difference between the highest and the second highest CO2 emissions (% of total fuel combustion) in 1963?
Make the answer very short. 0. What is the difference between the highest and the lowest CO2 emissions (% of total fuel combustion) of 1960?
Provide a succinct answer. 4.74. What is the difference between the highest and the lowest CO2 emissions (% of total fuel combustion) in 1961?
Your answer should be compact. 3.51. What is the difference between the highest and the lowest CO2 emissions (% of total fuel combustion) of 1962?
Ensure brevity in your answer.  2.55. What is the difference between the highest and the lowest CO2 emissions (% of total fuel combustion) of 1963?
Offer a very short reply. 7.27. 